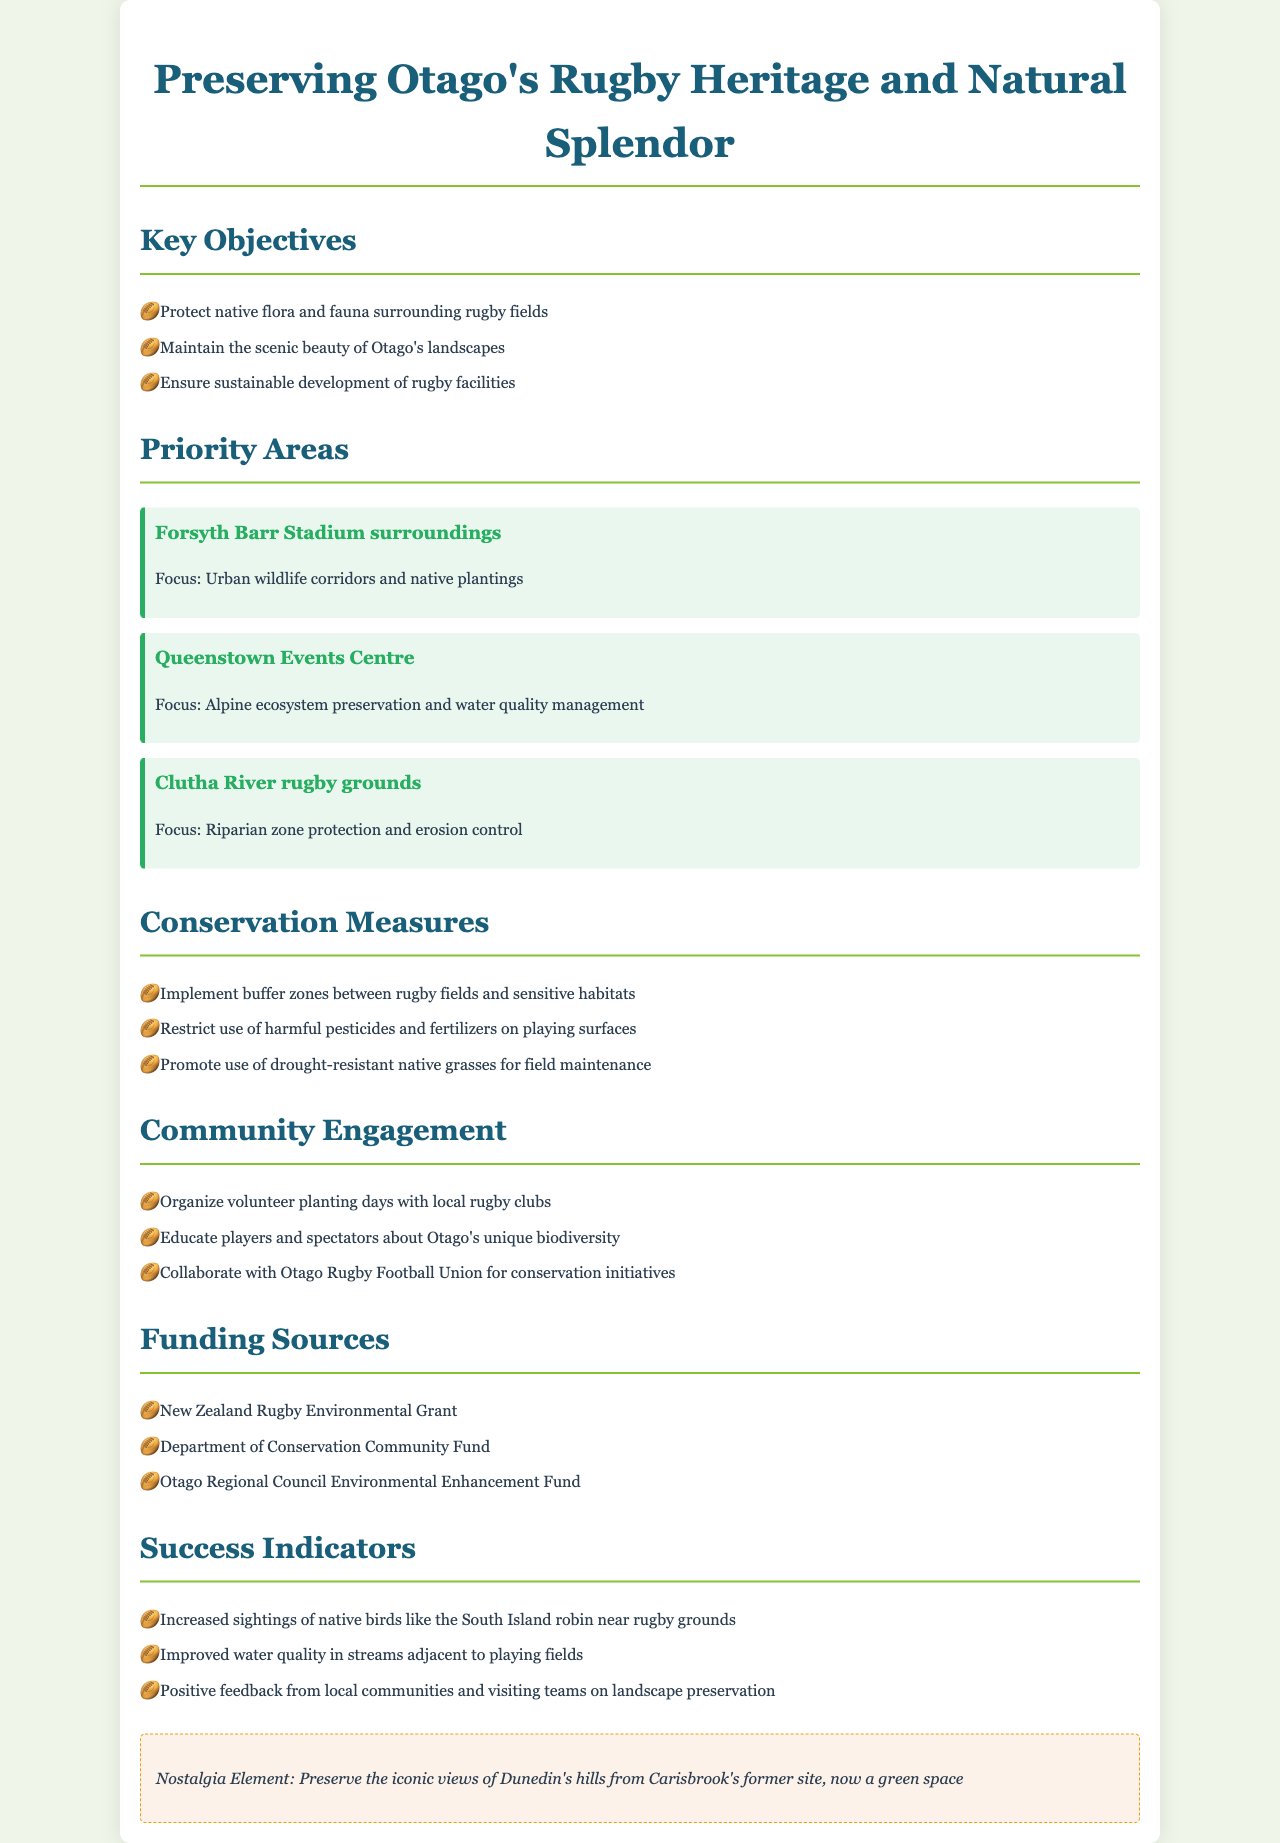what are the key objectives of the policy? The key objectives detail the goals of the environmental protection policy in preserving Otago's natural landscapes and wildlife, focusing on three main areas.
Answer: Protect native flora and fauna surrounding rugby fields, Maintain the scenic beauty of Otago's landscapes, Ensure sustainable development of rugby facilities which rugby ground focuses on riparian zone protection? The document specifies priority areas that focus on particular environmental needs; identifying the one related to riparian zones helps to understand the conservation priorities.
Answer: Clutha River rugby grounds how many funding sources are mentioned? The number of funding sources gives an indication of the financial support available for the initiatives in the policy.
Answer: Three what is one of the success indicators mentioned? Success indicators help to measure the effectiveness of the policy; knowing one provides insight into the anticipated outcomes.
Answer: Increased sightings of native birds like the South Island robin near rugby grounds what does community engagement involve? Understanding community engagement activities showcases how the policy intends to involve the public and local rugby clubs in conservation efforts.
Answer: Organize volunteer planting days with local rugby clubs 